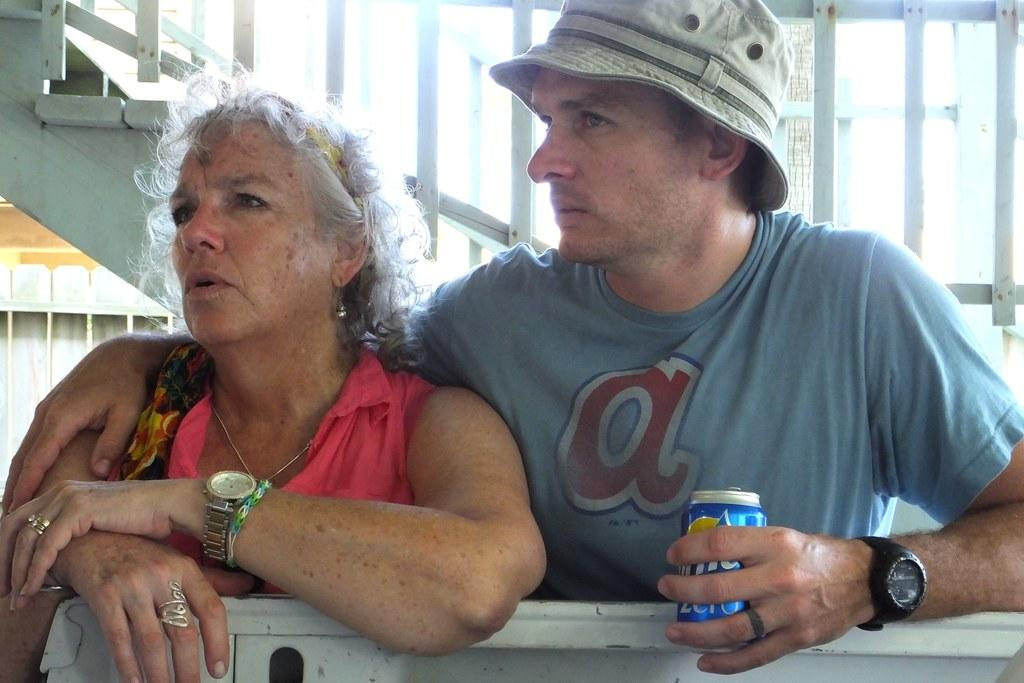What is the man in the image doing? The man is standing in the image and holding a tin. Who is with the man in the image? There is a lady next to the man in the image. What can be seen in the background of the image? Stairs and railings are visible in the background of the image. What type of zephyr can be seen blowing through the lady's hair in the image? There is no zephyr present in the image, and the lady's hair is not shown blowing in any direction. 